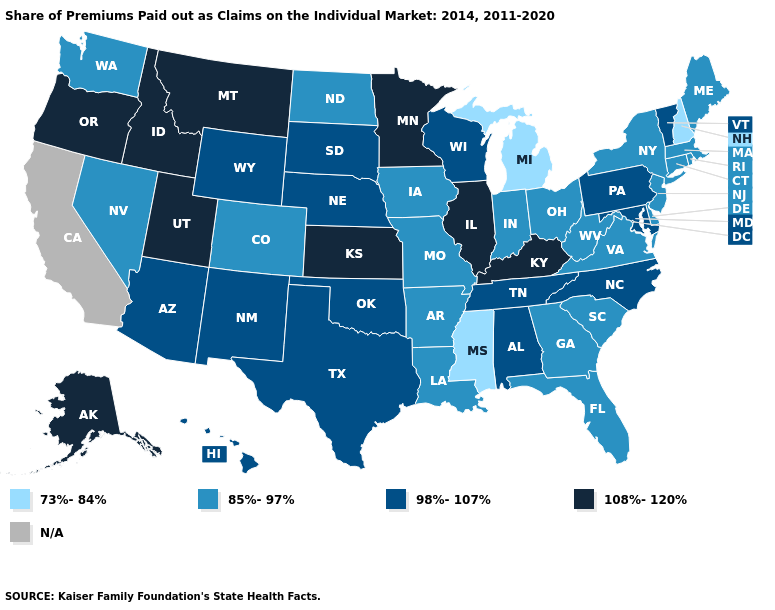Does West Virginia have the highest value in the South?
Quick response, please. No. Among the states that border New Jersey , does New York have the highest value?
Answer briefly. No. How many symbols are there in the legend?
Keep it brief. 5. What is the value of Alaska?
Give a very brief answer. 108%-120%. Which states have the highest value in the USA?
Write a very short answer. Alaska, Idaho, Illinois, Kansas, Kentucky, Minnesota, Montana, Oregon, Utah. What is the value of West Virginia?
Give a very brief answer. 85%-97%. What is the lowest value in the West?
Write a very short answer. 85%-97%. What is the lowest value in the MidWest?
Answer briefly. 73%-84%. Which states have the lowest value in the USA?
Write a very short answer. Michigan, Mississippi, New Hampshire. What is the value of Georgia?
Write a very short answer. 85%-97%. What is the highest value in the USA?
Write a very short answer. 108%-120%. What is the lowest value in the USA?
Concise answer only. 73%-84%. Among the states that border Virginia , does Kentucky have the highest value?
Write a very short answer. Yes. Does New Hampshire have the lowest value in the Northeast?
Quick response, please. Yes. What is the highest value in the Northeast ?
Write a very short answer. 98%-107%. 